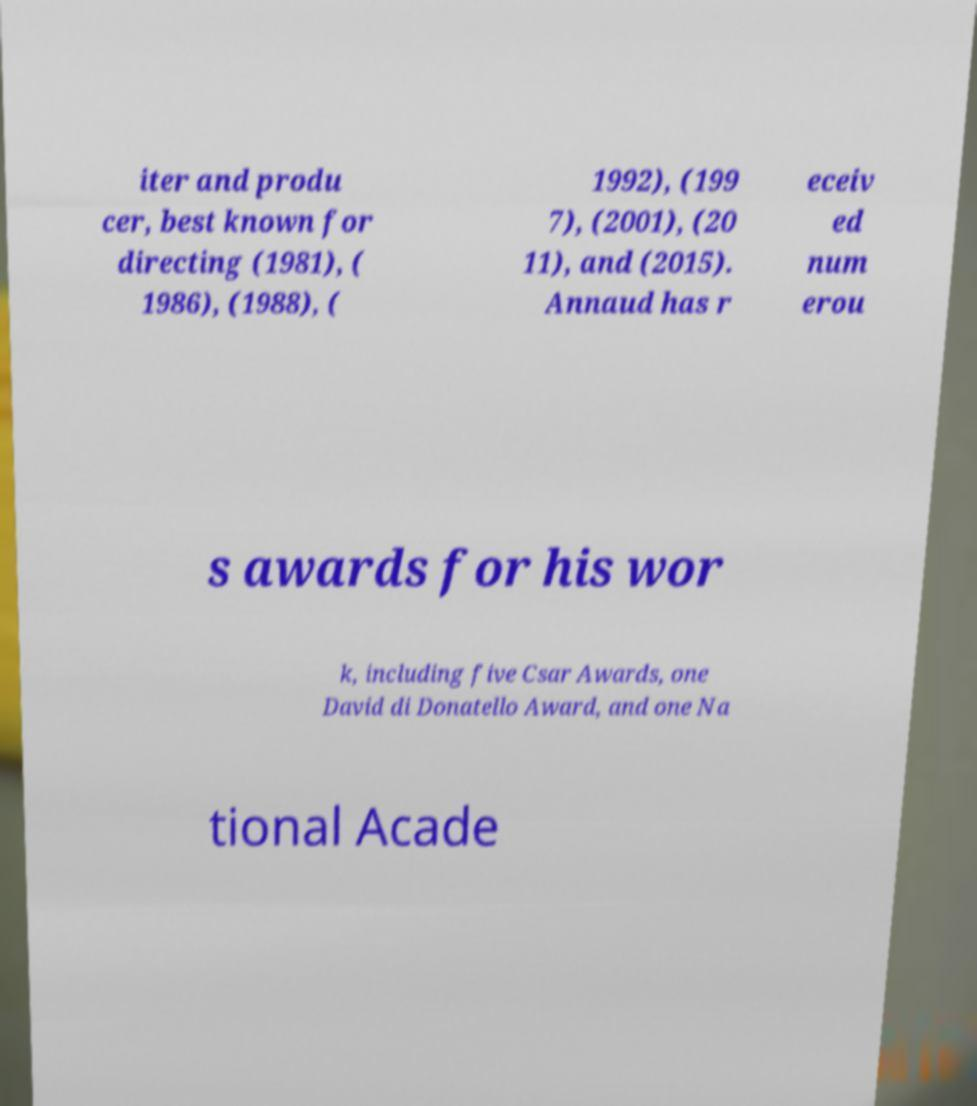Could you extract and type out the text from this image? iter and produ cer, best known for directing (1981), ( 1986), (1988), ( 1992), (199 7), (2001), (20 11), and (2015). Annaud has r eceiv ed num erou s awards for his wor k, including five Csar Awards, one David di Donatello Award, and one Na tional Acade 